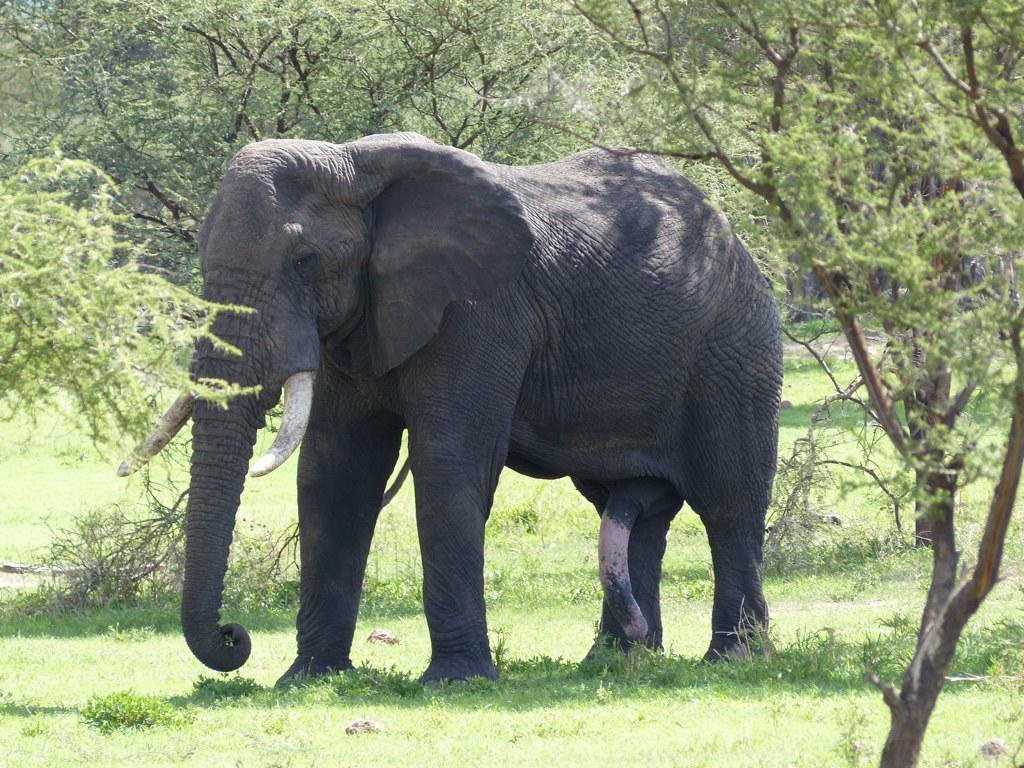What animal is the main subject of the picture? There is an elephant in the picture. What is the elephant standing on? The elephant is standing on the grass. What can be seen in the background of the picture? There are trees in the background of the picture. What type of beef is being served at the picnic in the image? There is no picnic or beef present in the image; it features an elephant standing on the grass with trees in the background. 